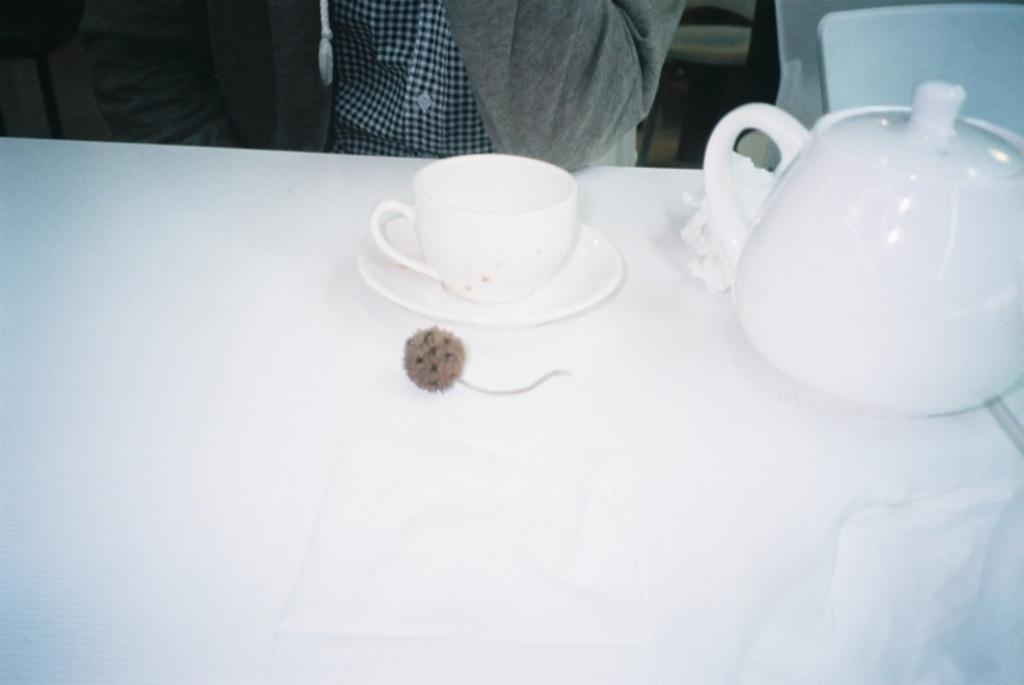What is on the table in the image? There is a teapot, a cup, and a saucer on the table. What else can be seen near the table? There are people standing near the table. What month is it in the image, and how does the robin show respect to the people near the table? There is no mention of a robin or a specific month in the image. The image only shows a teapot, a cup, a saucer, and people standing near the table. 